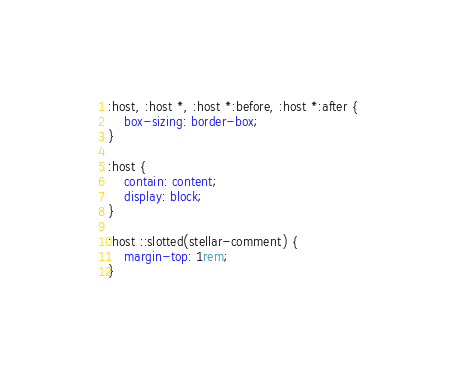<code> <loc_0><loc_0><loc_500><loc_500><_CSS_>:host, :host *, :host *:before, :host *:after {
	box-sizing: border-box;
}

:host {
	contain: content;
	display: block;
}

:host ::slotted(stellar-comment) {
	margin-top: 1rem;
}
</code> 